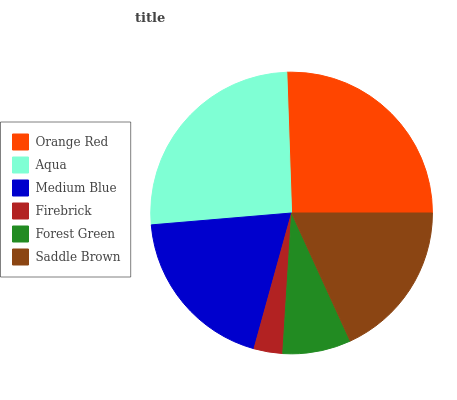Is Firebrick the minimum?
Answer yes or no. Yes. Is Aqua the maximum?
Answer yes or no. Yes. Is Medium Blue the minimum?
Answer yes or no. No. Is Medium Blue the maximum?
Answer yes or no. No. Is Aqua greater than Medium Blue?
Answer yes or no. Yes. Is Medium Blue less than Aqua?
Answer yes or no. Yes. Is Medium Blue greater than Aqua?
Answer yes or no. No. Is Aqua less than Medium Blue?
Answer yes or no. No. Is Medium Blue the high median?
Answer yes or no. Yes. Is Saddle Brown the low median?
Answer yes or no. Yes. Is Saddle Brown the high median?
Answer yes or no. No. Is Forest Green the low median?
Answer yes or no. No. 